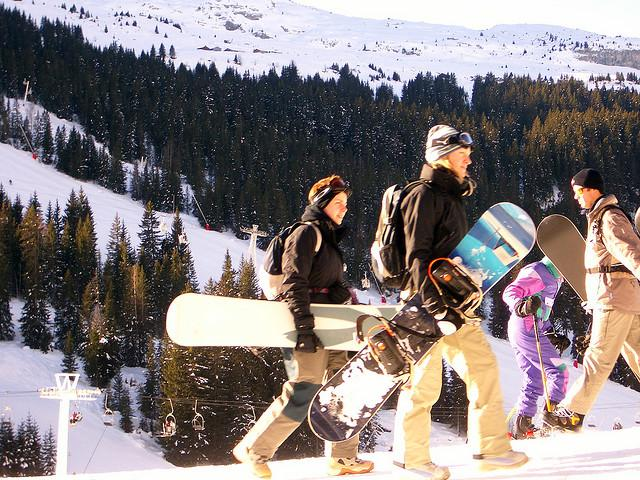What are these people in the front carrying? Please explain your reasoning. snowboards. They are using these to glide down the mountain alongside skiers. 